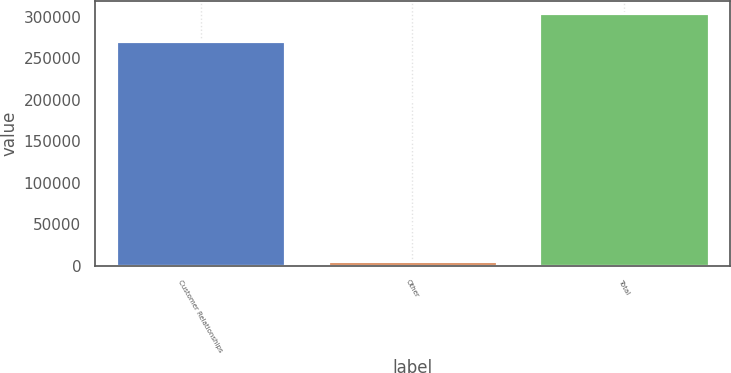Convert chart to OTSL. <chart><loc_0><loc_0><loc_500><loc_500><bar_chart><fcel>Customer Relationships<fcel>Other<fcel>Total<nl><fcel>271123<fcel>6084<fcel>304192<nl></chart> 